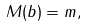<formula> <loc_0><loc_0><loc_500><loc_500>M ( b ) = m ,</formula> 